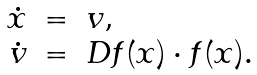Convert formula to latex. <formula><loc_0><loc_0><loc_500><loc_500>\begin{array} { r c l } \dot { x } & = & v , \\ \dot { v } & = & D f ( x ) \cdot f ( x ) . \end{array}</formula> 